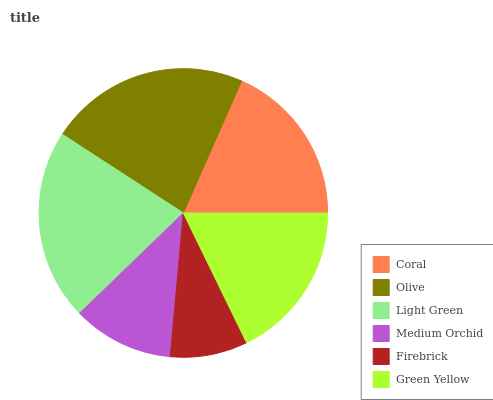Is Firebrick the minimum?
Answer yes or no. Yes. Is Olive the maximum?
Answer yes or no. Yes. Is Light Green the minimum?
Answer yes or no. No. Is Light Green the maximum?
Answer yes or no. No. Is Olive greater than Light Green?
Answer yes or no. Yes. Is Light Green less than Olive?
Answer yes or no. Yes. Is Light Green greater than Olive?
Answer yes or no. No. Is Olive less than Light Green?
Answer yes or no. No. Is Coral the high median?
Answer yes or no. Yes. Is Green Yellow the low median?
Answer yes or no. Yes. Is Medium Orchid the high median?
Answer yes or no. No. Is Olive the low median?
Answer yes or no. No. 